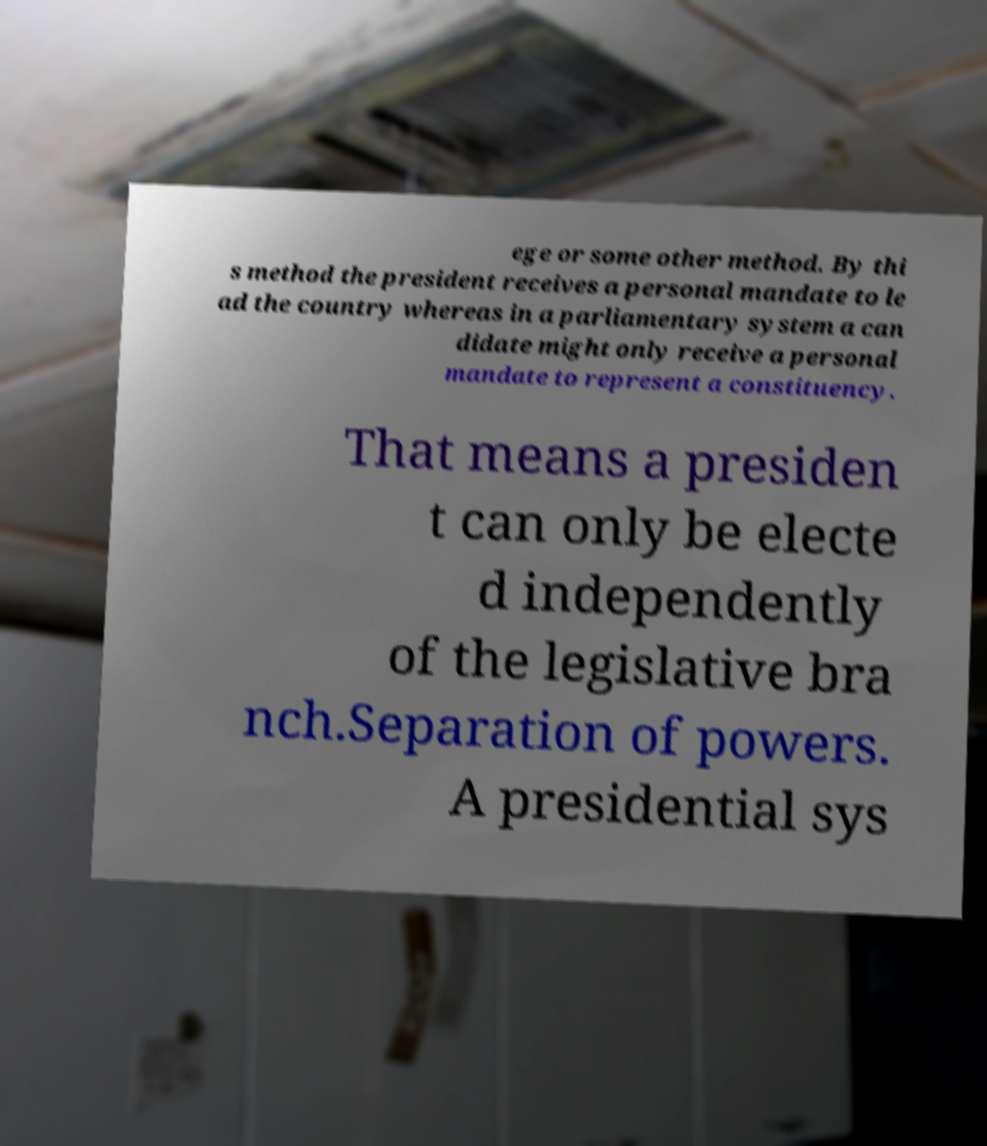I need the written content from this picture converted into text. Can you do that? ege or some other method. By thi s method the president receives a personal mandate to le ad the country whereas in a parliamentary system a can didate might only receive a personal mandate to represent a constituency. That means a presiden t can only be electe d independently of the legislative bra nch.Separation of powers. A presidential sys 